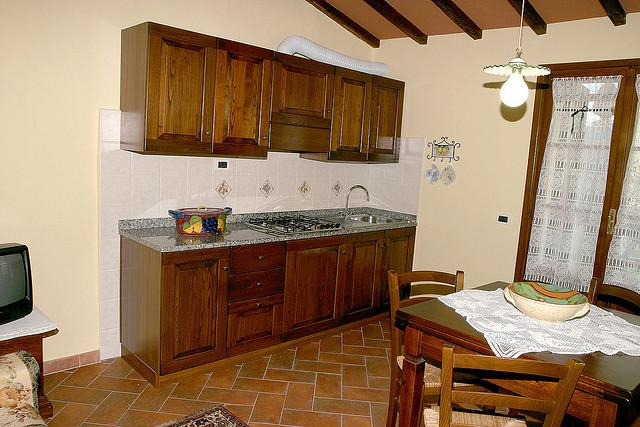What is the white tube on top of the cabinet used for? ventilation 